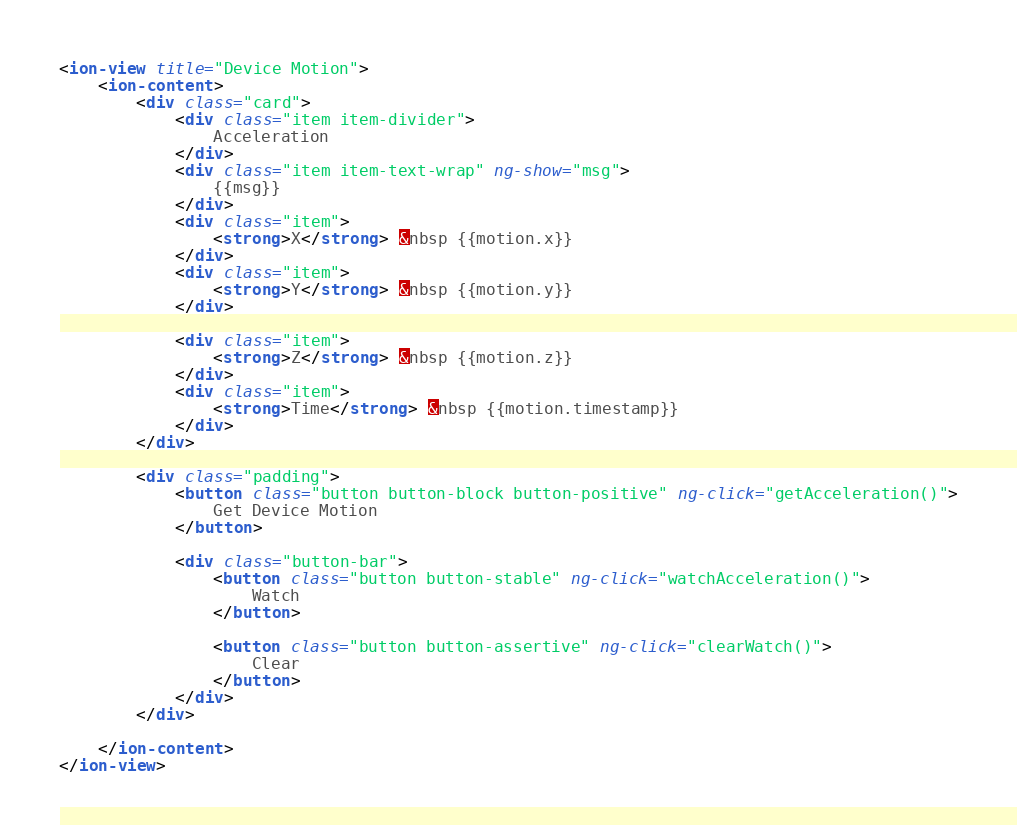<code> <loc_0><loc_0><loc_500><loc_500><_HTML_><ion-view title="Device Motion">
	<ion-content>
		<div class="card">
			<div class="item item-divider">
				Acceleration
			</div>
			<div class="item item-text-wrap" ng-show="msg">
				{{msg}}
			</div>
			<div class="item">
				<strong>X</strong> &nbsp {{motion.x}}
			</div>
			<div class="item">
				<strong>Y</strong> &nbsp {{motion.y}}
			</div>

			<div class="item">
				<strong>Z</strong> &nbsp {{motion.z}}
			</div>
			<div class="item">
				<strong>Time</strong> &nbsp {{motion.timestamp}}
			</div>
		</div>

		<div class="padding">
			<button class="button button-block button-positive" ng-click="getAcceleration()">
				Get Device Motion
			</button>

			<div class="button-bar">
				<button class="button button-stable" ng-click="watchAcceleration()">
					Watch
				</button>

				<button class="button button-assertive" ng-click="clearWatch()">
					Clear
				</button>
			</div>
		</div>

	</ion-content>
</ion-view>
</code> 